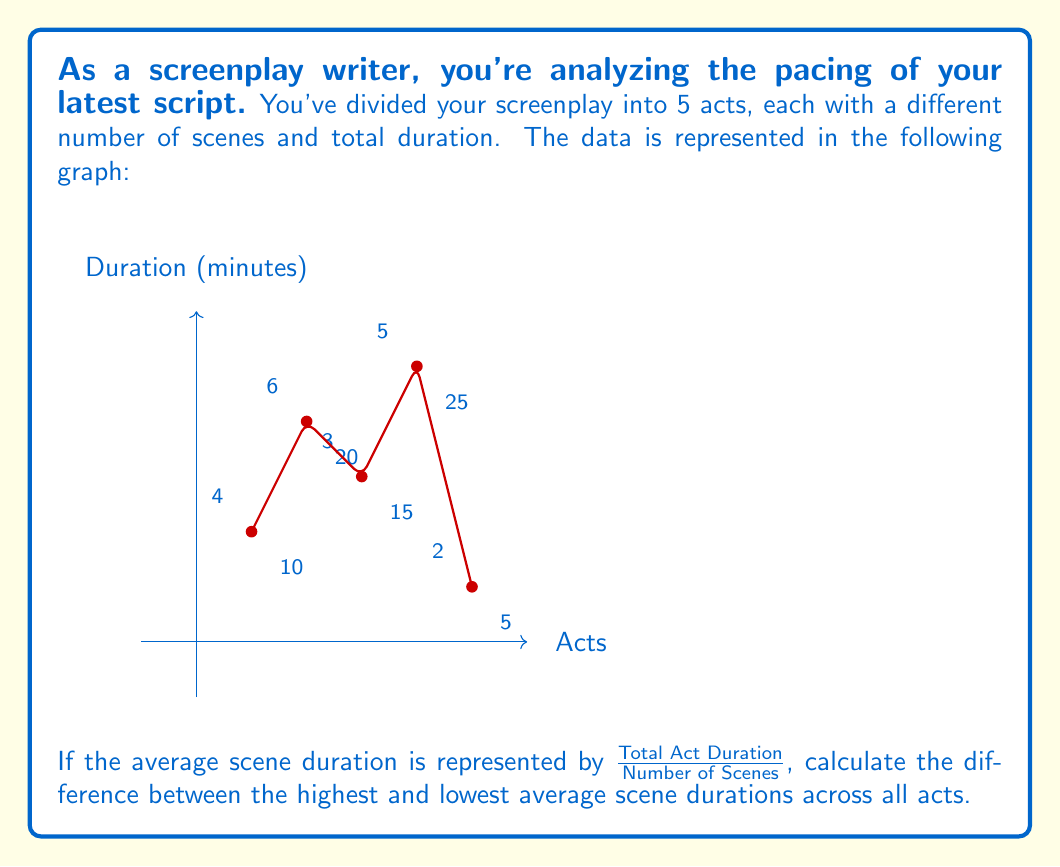Give your solution to this math problem. Let's approach this step-by-step:

1) First, calculate the average scene duration for each act:

   Act 1: $\frac{10 \text{ minutes}}{4 \text{ scenes}} = 2.5 \text{ minutes/scene}$
   Act 2: $\frac{20 \text{ minutes}}{6 \text{ scenes}} = 3.33 \text{ minutes/scene}$
   Act 3: $\frac{15 \text{ minutes}}{3 \text{ scenes}} = 5 \text{ minutes/scene}$
   Act 4: $\frac{25 \text{ minutes}}{5 \text{ scenes}} = 5 \text{ minutes/scene}$
   Act 5: $\frac{5 \text{ minutes}}{2 \text{ scenes}} = 2.5 \text{ minutes/scene}$

2) Identify the highest and lowest average scene durations:
   Highest: 5 minutes/scene (Acts 3 and 4)
   Lowest: 2.5 minutes/scene (Acts 1 and 5)

3) Calculate the difference:
   $5 \text{ minutes/scene} - 2.5 \text{ minutes/scene} = 2.5 \text{ minutes/scene}$

This difference represents the range in pacing across your screenplay, with some acts having significantly longer average scene durations than others.
Answer: 2.5 minutes/scene 